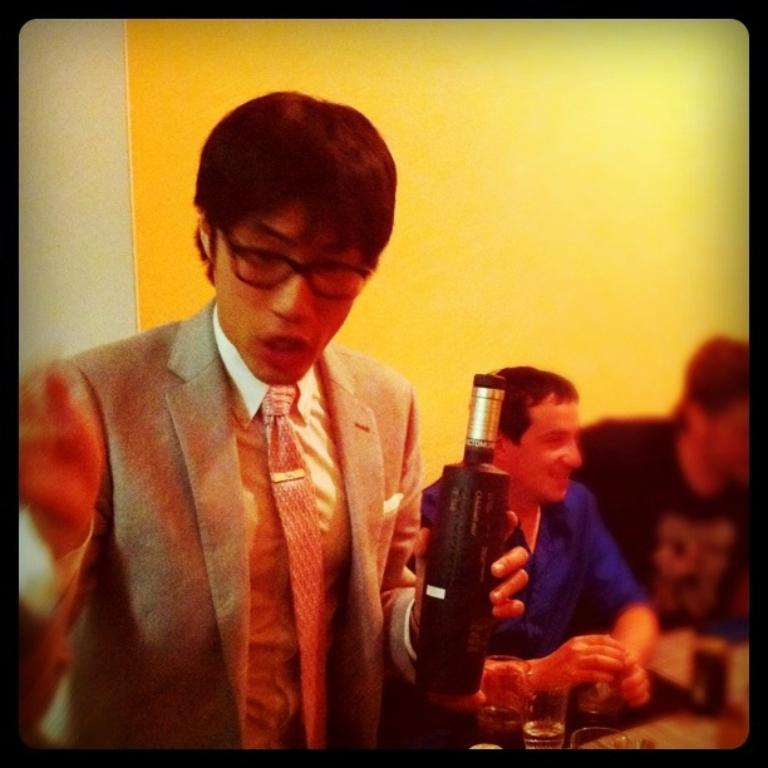What can be observed about the people in the image? There is a group of people in the image, with some people seated. Can you describe the man on the left side of the image? The man on the left side of the image is wearing spectacles. What is the man holding in his hand? The man is holding a bottle in his hand. What type of duck is sitting on the flame in the image? There is no duck or flame present in the image. 